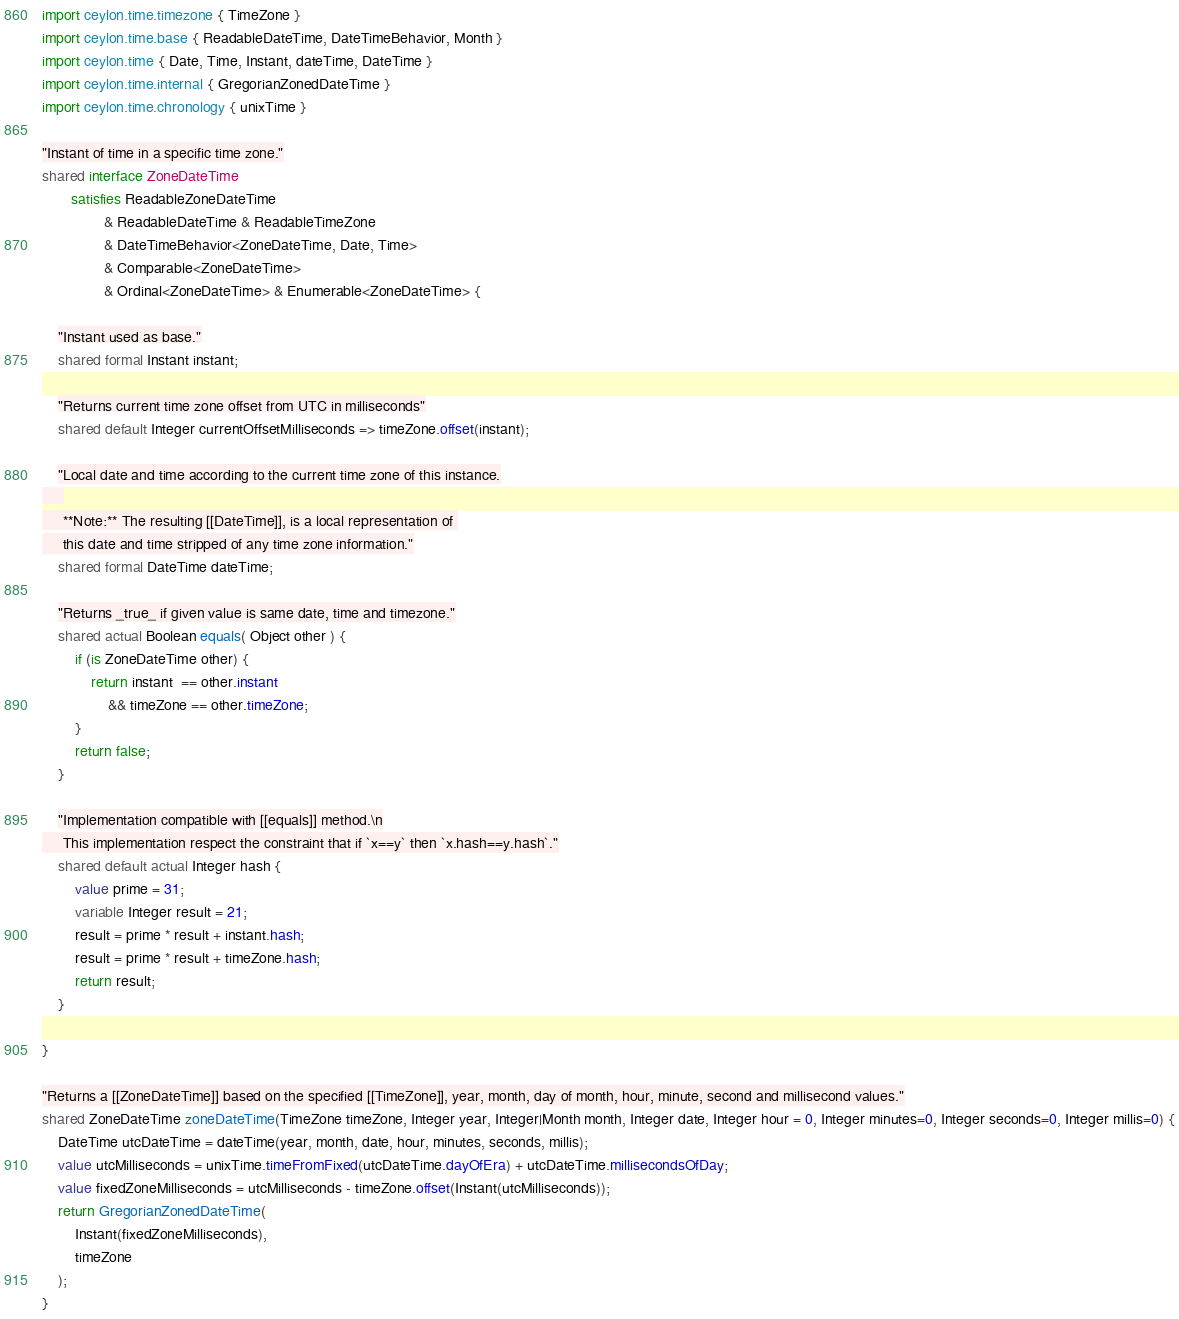<code> <loc_0><loc_0><loc_500><loc_500><_Ceylon_>import ceylon.time.timezone { TimeZone }
import ceylon.time.base { ReadableDateTime, DateTimeBehavior, Month }
import ceylon.time { Date, Time, Instant, dateTime, DateTime }
import ceylon.time.internal { GregorianZonedDateTime }
import ceylon.time.chronology { unixTime }

"Instant of time in a specific time zone."
shared interface ZoneDateTime
       satisfies ReadableZoneDateTime
               & ReadableDateTime & ReadableTimeZone
               & DateTimeBehavior<ZoneDateTime, Date, Time> 
               & Comparable<ZoneDateTime>
               & Ordinal<ZoneDateTime> & Enumerable<ZoneDateTime> {

    "Instant used as base."
    shared formal Instant instant;
    
    "Returns current time zone offset from UTC in milliseconds"
    shared default Integer currentOffsetMilliseconds => timeZone.offset(instant);
    
    "Local date and time according to the current time zone of this instance.
     
     **Note:** The resulting [[DateTime]], is a local representation of 
     this date and time stripped of any time zone information."
    shared formal DateTime dateTime;
    
    "Returns _true_ if given value is same date, time and timezone."
    shared actual Boolean equals( Object other ) {
        if (is ZoneDateTime other) {
            return instant  == other.instant 
                && timeZone == other.timeZone;
        }
        return false;
    }
    
    "Implementation compatible with [[equals]] method.\n
     This implementation respect the constraint that if `x==y` then `x.hash==y.hash`."
    shared default actual Integer hash {
        value prime = 31;
        variable Integer result = 21;
        result = prime * result + instant.hash;
        result = prime * result + timeZone.hash;
        return result;
    }
    
}

"Returns a [[ZoneDateTime]] based on the specified [[TimeZone]], year, month, day of month, hour, minute, second and millisecond values."
shared ZoneDateTime zoneDateTime(TimeZone timeZone, Integer year, Integer|Month month, Integer date, Integer hour = 0, Integer minutes=0, Integer seconds=0, Integer millis=0) {
    DateTime utcDateTime = dateTime(year, month, date, hour, minutes, seconds, millis);
    value utcMilliseconds = unixTime.timeFromFixed(utcDateTime.dayOfEra) + utcDateTime.millisecondsOfDay;
    value fixedZoneMilliseconds = utcMilliseconds - timeZone.offset(Instant(utcMilliseconds));
    return GregorianZonedDateTime(
        Instant(fixedZoneMilliseconds),
        timeZone
    );
}
</code> 